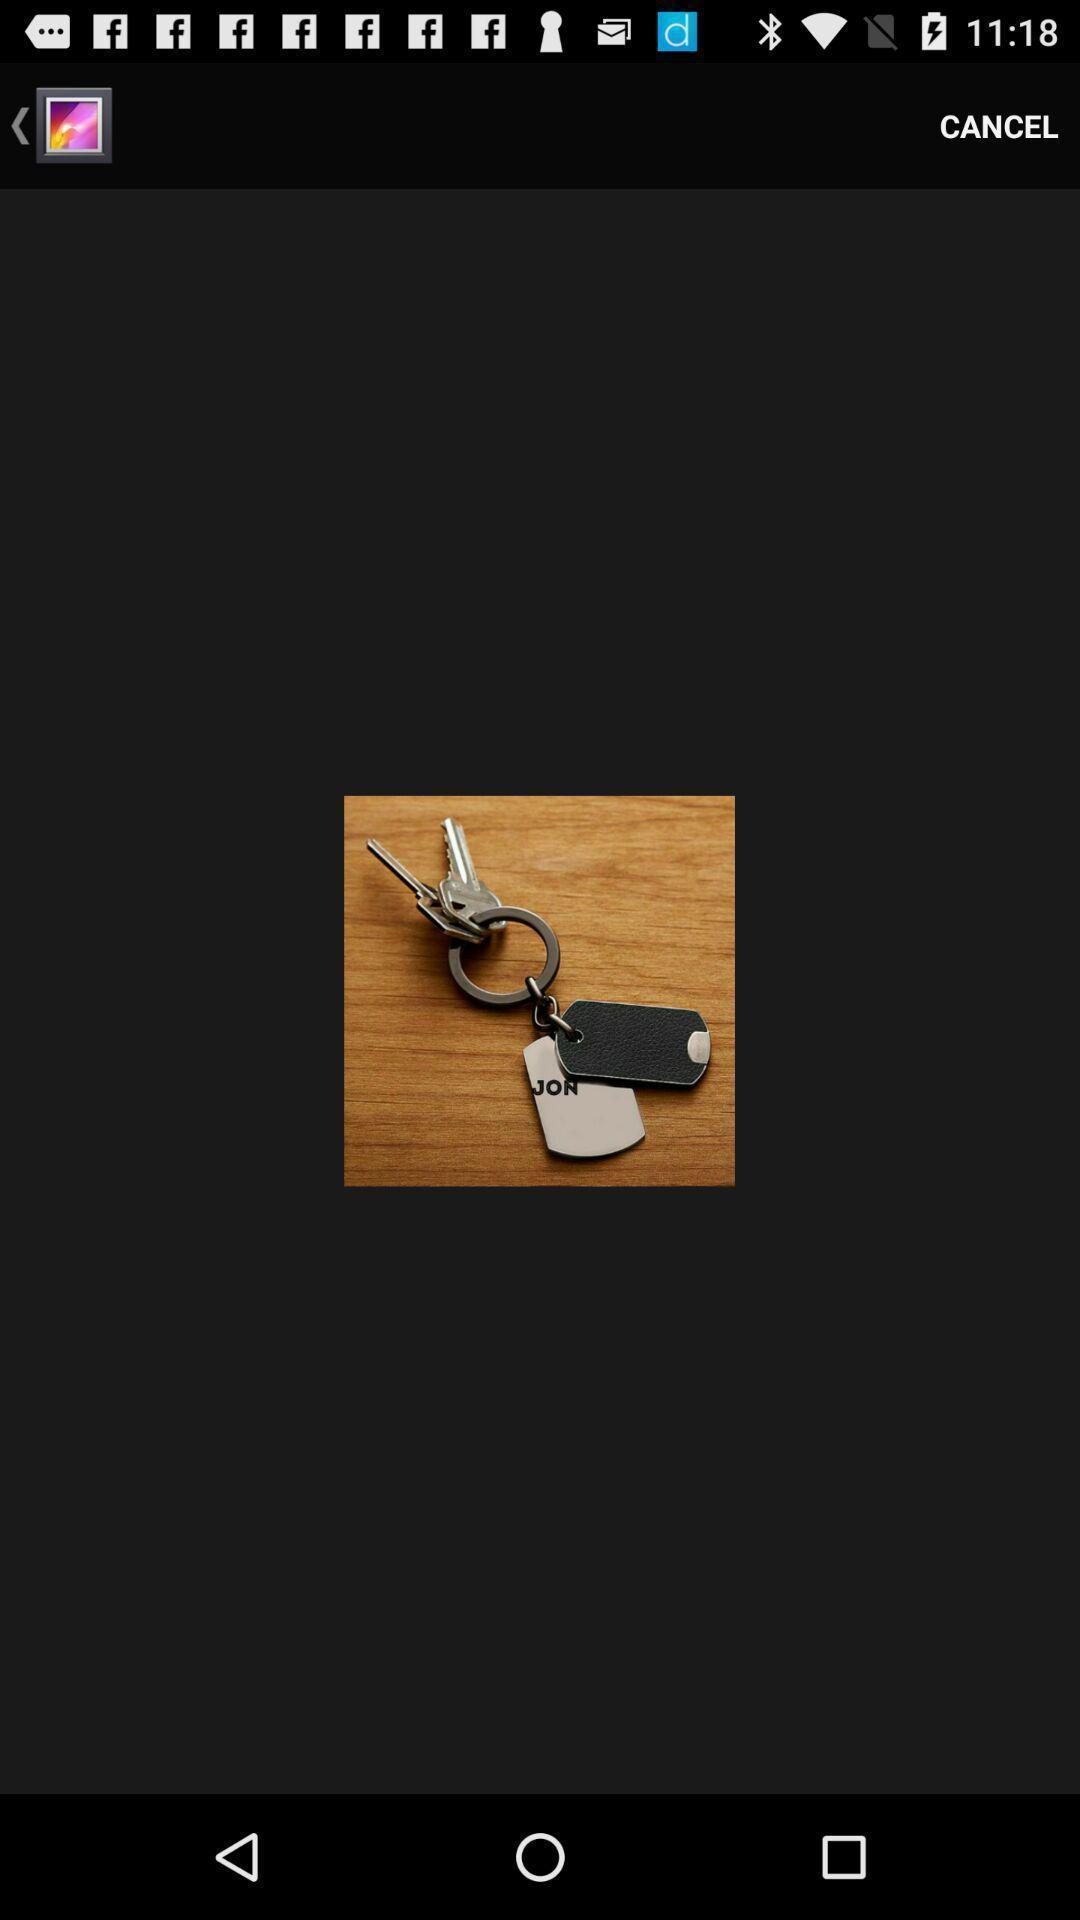Provide a description of this screenshot. Screen showing an image. 